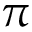Convert formula to latex. <formula><loc_0><loc_0><loc_500><loc_500>\pi</formula> 